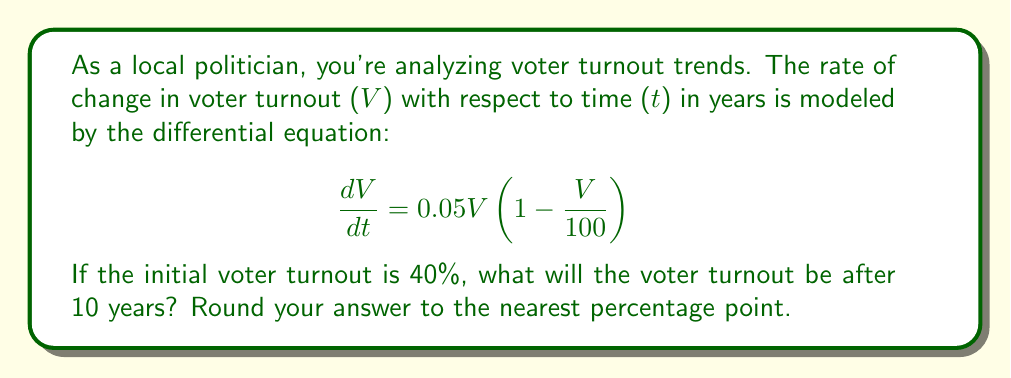Provide a solution to this math problem. To solve this problem, we need to use the logistic growth model, which is a first-order differential equation. Let's approach this step-by-step:

1) The given differential equation is in the form of the logistic growth model:

   $$\frac{dV}{dt} = rV(1 - \frac{V}{K})$$

   Where $r = 0.05$ is the growth rate and $K = 100$ is the carrying capacity.

2) The solution to this differential equation is:

   $$V(t) = \frac{K}{1 + (\frac{K}{V_0} - 1)e^{-rt}}$$

   Where $V_0$ is the initial voter turnout.

3) We're given that $V_0 = 40$, $K = 100$, $r = 0.05$, and we need to find $V(10)$.

4) Let's substitute these values into our solution:

   $$V(10) = \frac{100}{1 + (\frac{100}{40} - 1)e^{-0.05(10)}}$$

5) Simplify:
   $$V(10) = \frac{100}{1 + 1.5e^{-0.5}}$$

6) Calculate:
   $$V(10) = \frac{100}{1 + 1.5(0.6065)} \approx 52.34$$

7) Rounding to the nearest percentage point:
   $V(10) \approx 52\%$
Answer: 52% 